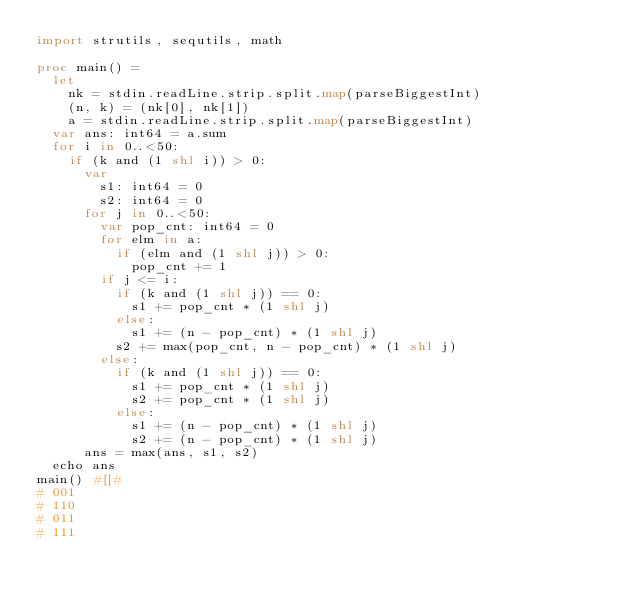Convert code to text. <code><loc_0><loc_0><loc_500><loc_500><_Nim_>import strutils, sequtils, math

proc main() =
  let
    nk = stdin.readLine.strip.split.map(parseBiggestInt)
    (n, k) = (nk[0], nk[1])
    a = stdin.readLine.strip.split.map(parseBiggestInt)
  var ans: int64 = a.sum
  for i in 0..<50:
    if (k and (1 shl i)) > 0:
      var
        s1: int64 = 0
        s2: int64 = 0
      for j in 0..<50:
        var pop_cnt: int64 = 0
        for elm in a:
          if (elm and (1 shl j)) > 0:
            pop_cnt += 1
        if j <= i:
          if (k and (1 shl j)) == 0:
            s1 += pop_cnt * (1 shl j)
          else:
            s1 += (n - pop_cnt) * (1 shl j)
          s2 += max(pop_cnt, n - pop_cnt) * (1 shl j)
        else:
          if (k and (1 shl j)) == 0:
            s1 += pop_cnt * (1 shl j)
            s2 += pop_cnt * (1 shl j)
          else:
            s1 += (n - pop_cnt) * (1 shl j)
            s2 += (n - pop_cnt) * (1 shl j)
      ans = max(ans, s1, s2)
  echo ans
main() #[]#
# 001
# 110
# 011
# 111
</code> 